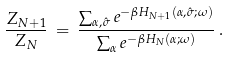Convert formula to latex. <formula><loc_0><loc_0><loc_500><loc_500>\frac { Z _ { N + 1 } } { Z _ { N } } \, = \, \frac { \sum _ { \alpha , \hat { \sigma } } e ^ { - \beta H _ { N + 1 } ( \alpha , \hat { \sigma } ; \omega ) } } { \sum _ { \alpha } e ^ { - \beta H _ { N } ( \alpha ; \omega ) } } \, .</formula> 